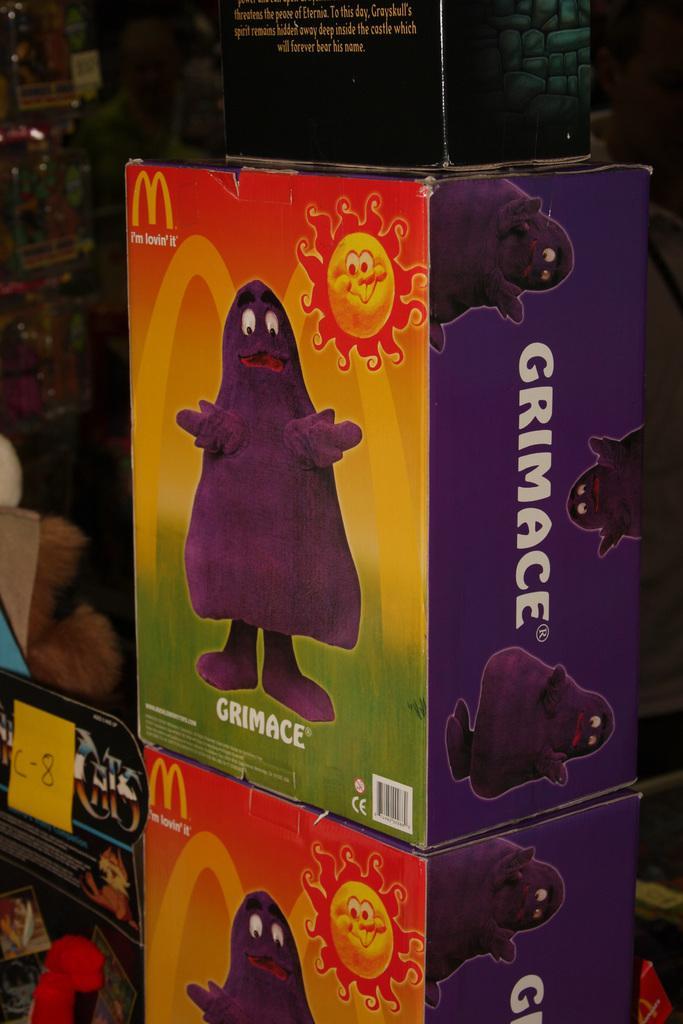Describe this image in one or two sentences. In the image we can see there are many boxes, on the box there is an animated picture and text. The background is dark. 